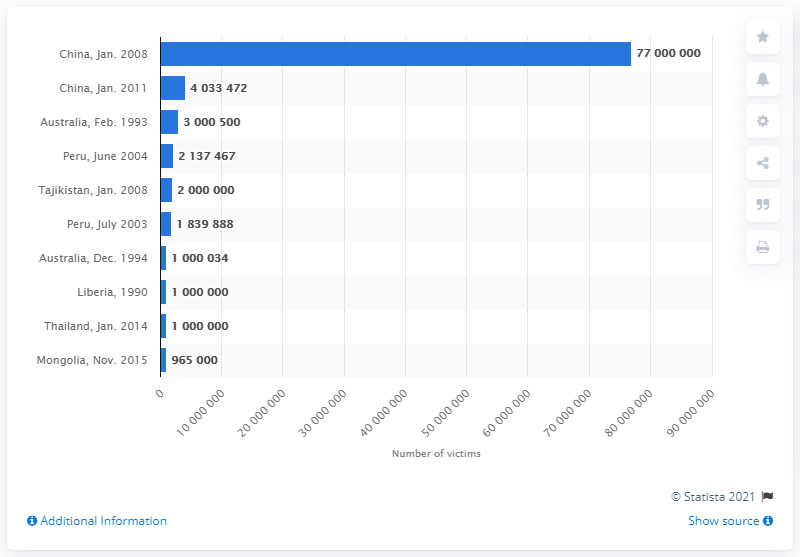Indicate a few pertinent items in this graphic. In January 2008, an estimated 77 million people in China were affected by a severe cold wave. 